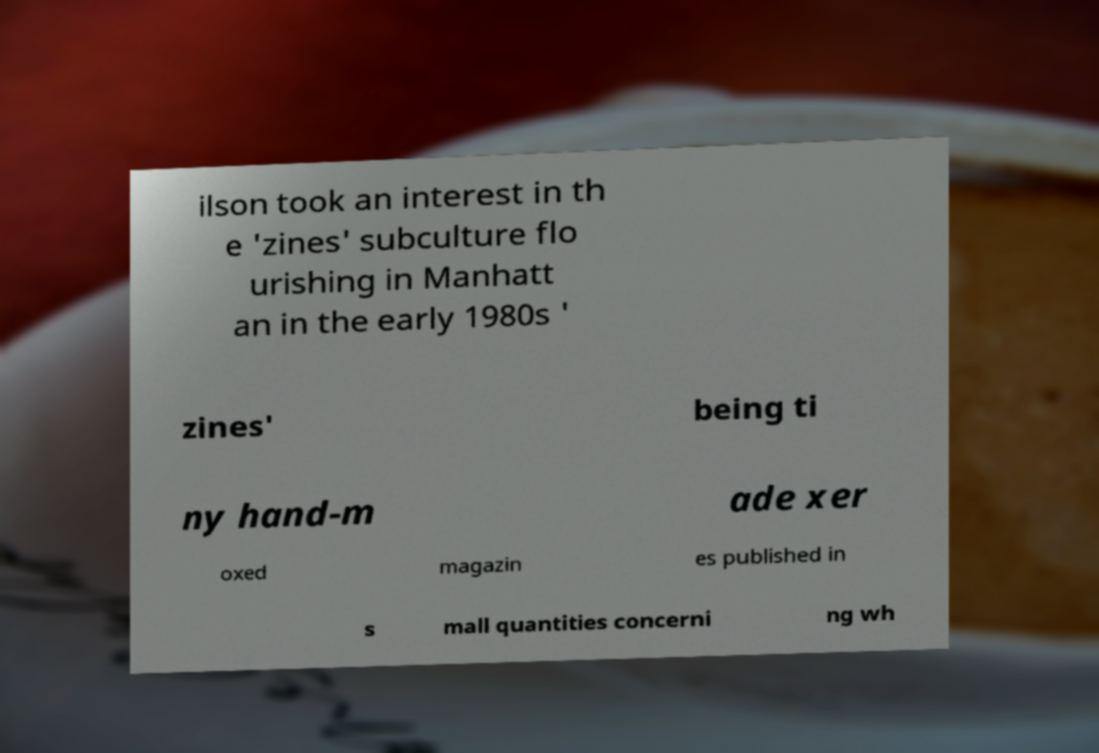Please read and relay the text visible in this image. What does it say? ilson took an interest in th e 'zines' subculture flo urishing in Manhatt an in the early 1980s ' zines' being ti ny hand-m ade xer oxed magazin es published in s mall quantities concerni ng wh 